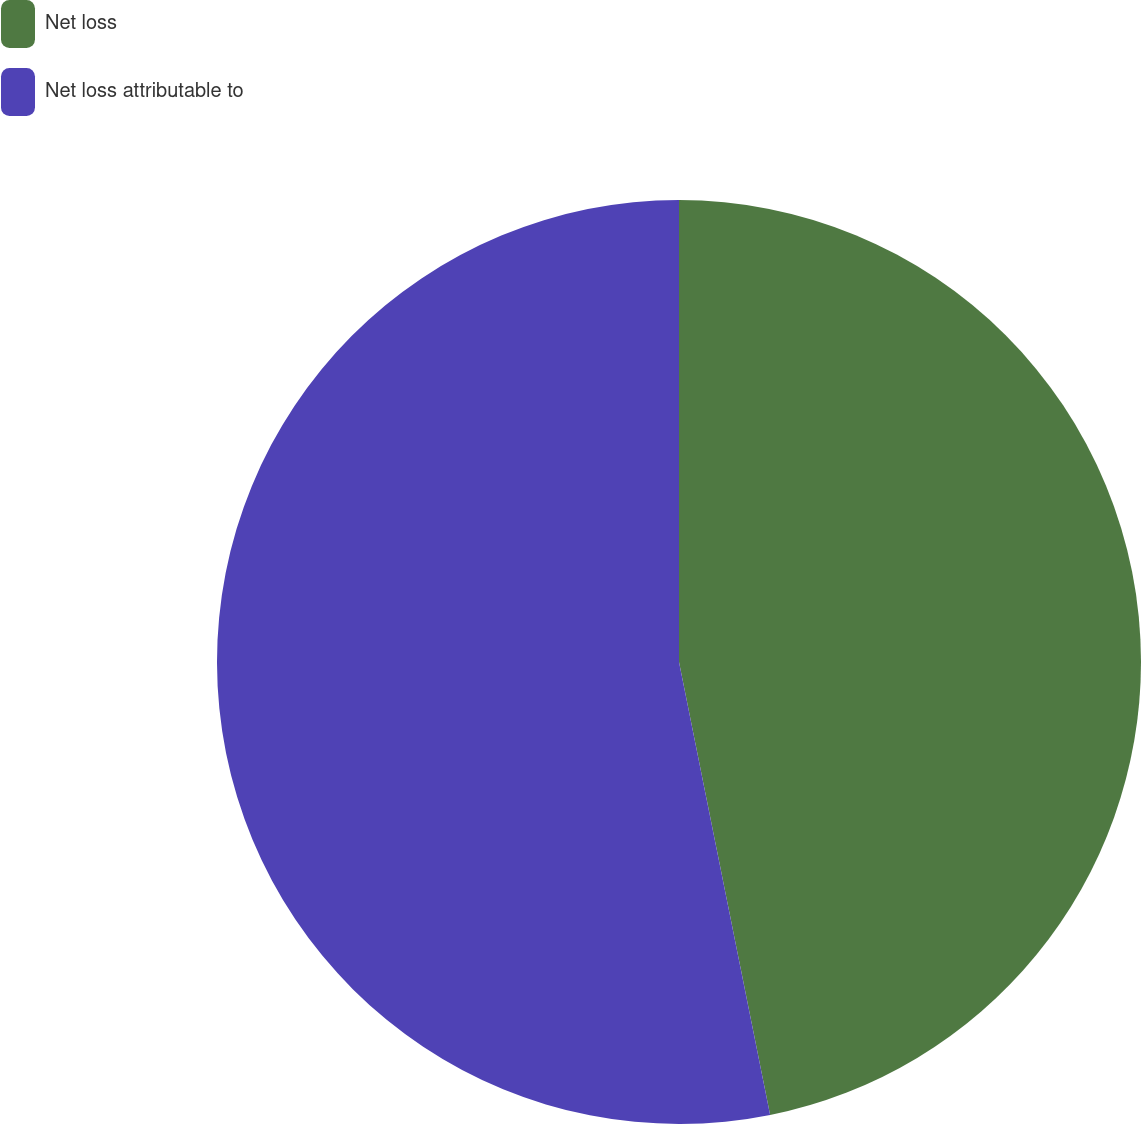<chart> <loc_0><loc_0><loc_500><loc_500><pie_chart><fcel>Net loss<fcel>Net loss attributable to<nl><fcel>46.84%<fcel>53.16%<nl></chart> 